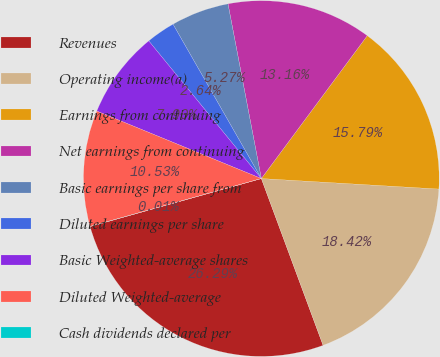Convert chart. <chart><loc_0><loc_0><loc_500><loc_500><pie_chart><fcel>Revenues<fcel>Operating income(a)<fcel>Earnings from continuing<fcel>Net earnings from continuing<fcel>Basic earnings per share from<fcel>Diluted earnings per share<fcel>Basic Weighted-average shares<fcel>Diluted Weighted-average<fcel>Cash dividends declared per<nl><fcel>26.3%<fcel>18.42%<fcel>15.79%<fcel>13.16%<fcel>5.27%<fcel>2.64%<fcel>7.9%<fcel>10.53%<fcel>0.01%<nl></chart> 